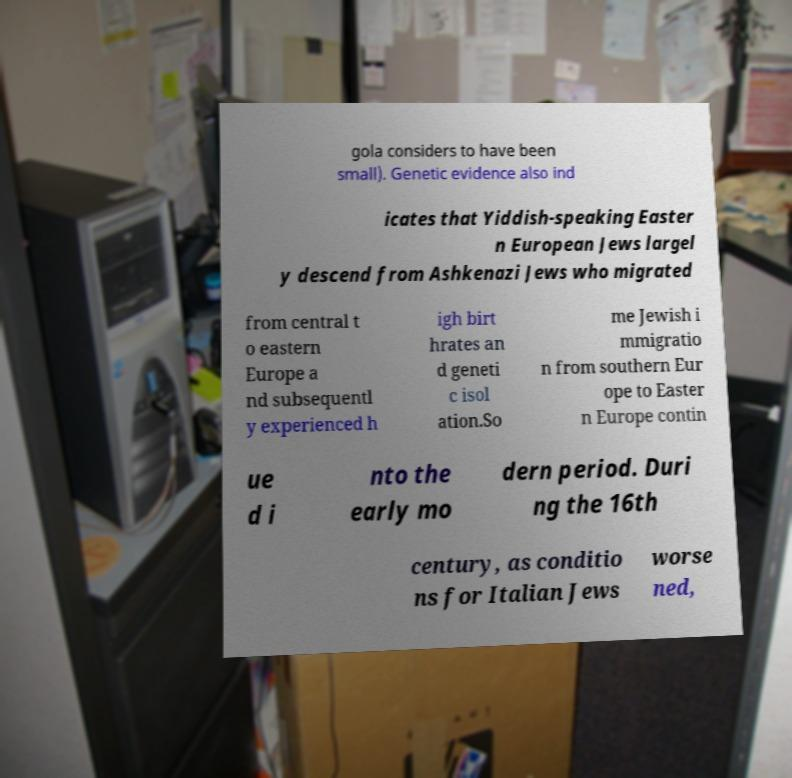There's text embedded in this image that I need extracted. Can you transcribe it verbatim? gola considers to have been small). Genetic evidence also ind icates that Yiddish-speaking Easter n European Jews largel y descend from Ashkenazi Jews who migrated from central t o eastern Europe a nd subsequentl y experienced h igh birt hrates an d geneti c isol ation.So me Jewish i mmigratio n from southern Eur ope to Easter n Europe contin ue d i nto the early mo dern period. Duri ng the 16th century, as conditio ns for Italian Jews worse ned, 